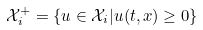<formula> <loc_0><loc_0><loc_500><loc_500>\mathcal { X } _ { i } ^ { + } = \{ u \in \mathcal { X } _ { i } | u ( t , x ) \geq 0 \}</formula> 